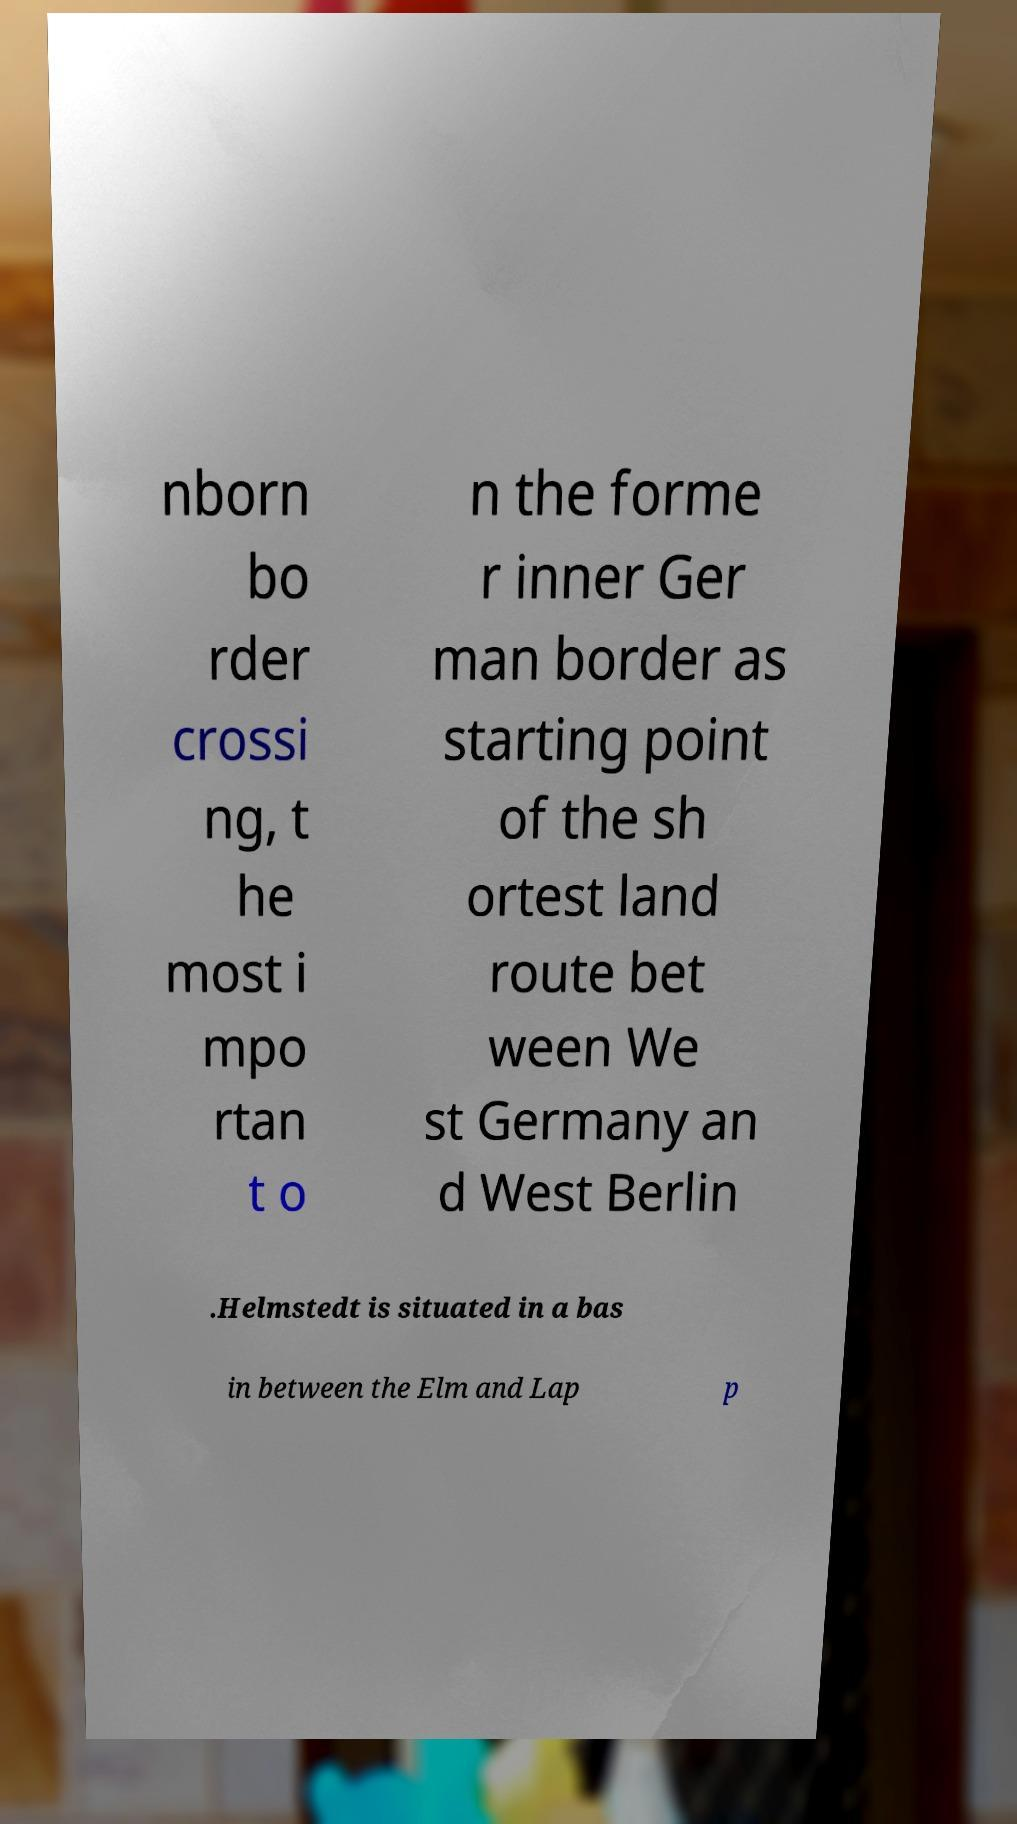Can you read and provide the text displayed in the image?This photo seems to have some interesting text. Can you extract and type it out for me? nborn bo rder crossi ng, t he most i mpo rtan t o n the forme r inner Ger man border as starting point of the sh ortest land route bet ween We st Germany an d West Berlin .Helmstedt is situated in a bas in between the Elm and Lap p 